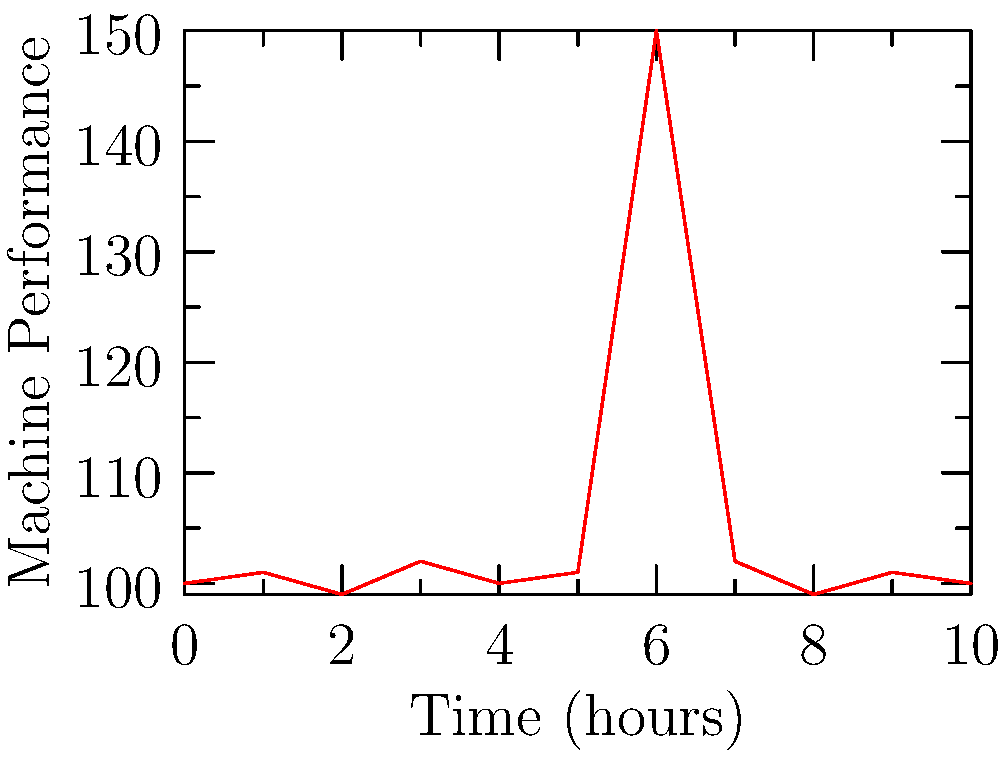As a factory worker monitoring machinery performance, you notice an unusual spike in the time series graph above. What type of anomaly detection technique would be most appropriate to identify this kind of sudden, short-lived deviation in machine performance? To answer this question, let's analyze the graph and consider the characteristics of the anomaly:

1. The graph shows machine performance over time.
2. Most of the data points fluctuate slightly around the 100 mark.
3. There is a sudden, significant spike at time t=6, reaching 150.
4. The spike is short-lived, as the performance returns to normal immediately after.

Given these observations, we can conclude that this is a point anomaly or spike anomaly. To detect such anomalies, we need a technique that can identify sudden, short-lived deviations from the normal pattern.

The most appropriate technique for this scenario is:

1. Statistical Process Control (SPC): This method uses control charts to monitor process variables and can easily detect sudden spikes that fall outside the normal range.

2. Moving Average: While useful for trend analysis, it might smooth out sudden spikes and is less suitable for detecting point anomalies.

3. ARIMA (AutoRegressive Integrated Moving Average): More suitable for detecting seasonal patterns and long-term trends rather than sudden spikes.

4. Isolation Forest: An machine learning algorithm that can detect anomalies but might be overly complex for this simple scenario.

Among these, Statistical Process Control (SPC) is the most appropriate and practical technique for a factory setting. It's easy to implement, interpret, and can quickly alert workers to sudden deviations in machine performance.
Answer: Statistical Process Control (SPC) 